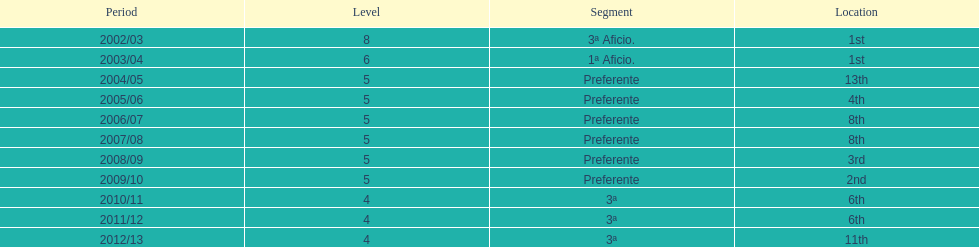How many years was the team in the 3 a division? 4. 